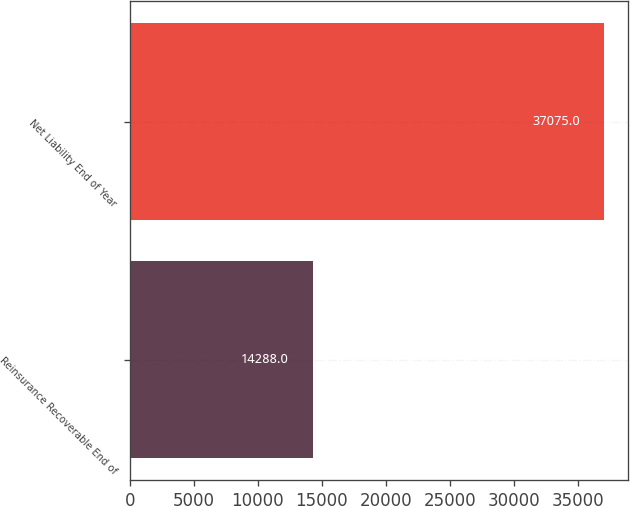<chart> <loc_0><loc_0><loc_500><loc_500><bar_chart><fcel>Reinsurance Recoverable End of<fcel>Net Liability End of Year<nl><fcel>14288<fcel>37075<nl></chart> 